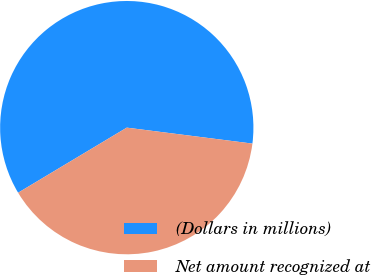<chart> <loc_0><loc_0><loc_500><loc_500><pie_chart><fcel>(Dollars in millions)<fcel>Net amount recognized at<nl><fcel>60.6%<fcel>39.4%<nl></chart> 